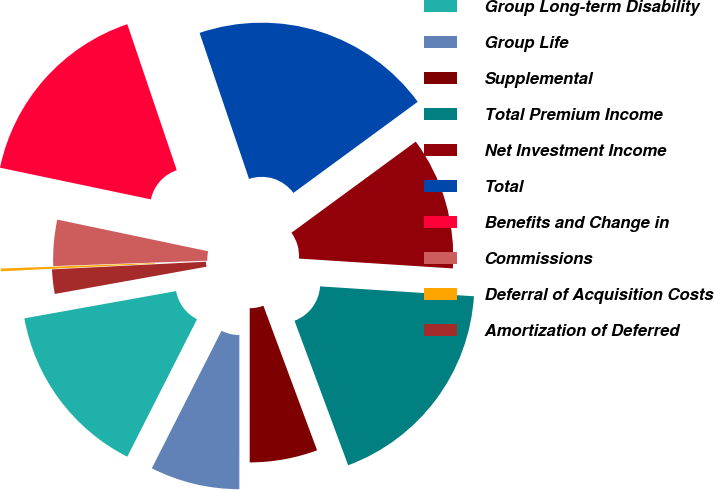Convert chart. <chart><loc_0><loc_0><loc_500><loc_500><pie_chart><fcel>Group Long-term Disability<fcel>Group Life<fcel>Supplemental<fcel>Total Premium Income<fcel>Net Investment Income<fcel>Total<fcel>Benefits and Change in<fcel>Commissions<fcel>Deferral of Acquisition Costs<fcel>Amortization of Deferred<nl><fcel>14.7%<fcel>7.47%<fcel>5.66%<fcel>18.32%<fcel>11.09%<fcel>20.13%<fcel>16.51%<fcel>3.85%<fcel>0.23%<fcel>2.04%<nl></chart> 